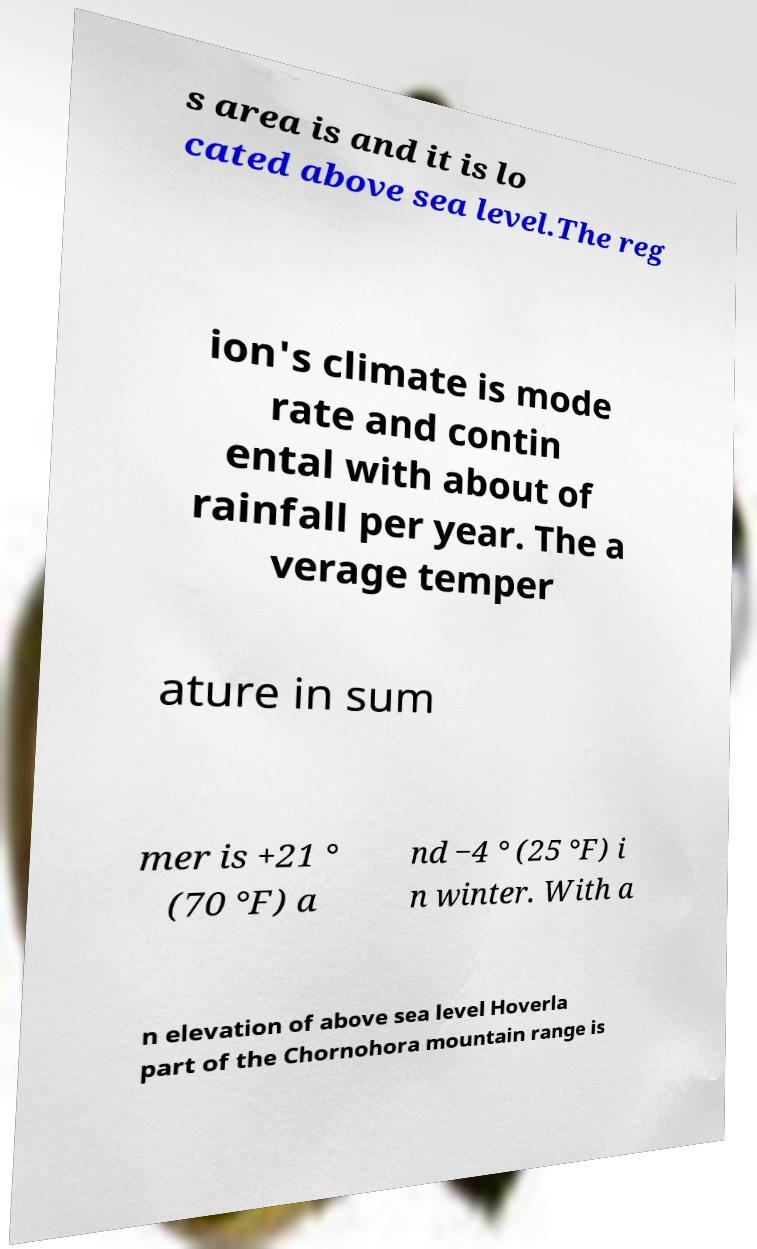What messages or text are displayed in this image? I need them in a readable, typed format. s area is and it is lo cated above sea level.The reg ion's climate is mode rate and contin ental with about of rainfall per year. The a verage temper ature in sum mer is +21 ° (70 °F) a nd −4 ° (25 °F) i n winter. With a n elevation of above sea level Hoverla part of the Chornohora mountain range is 